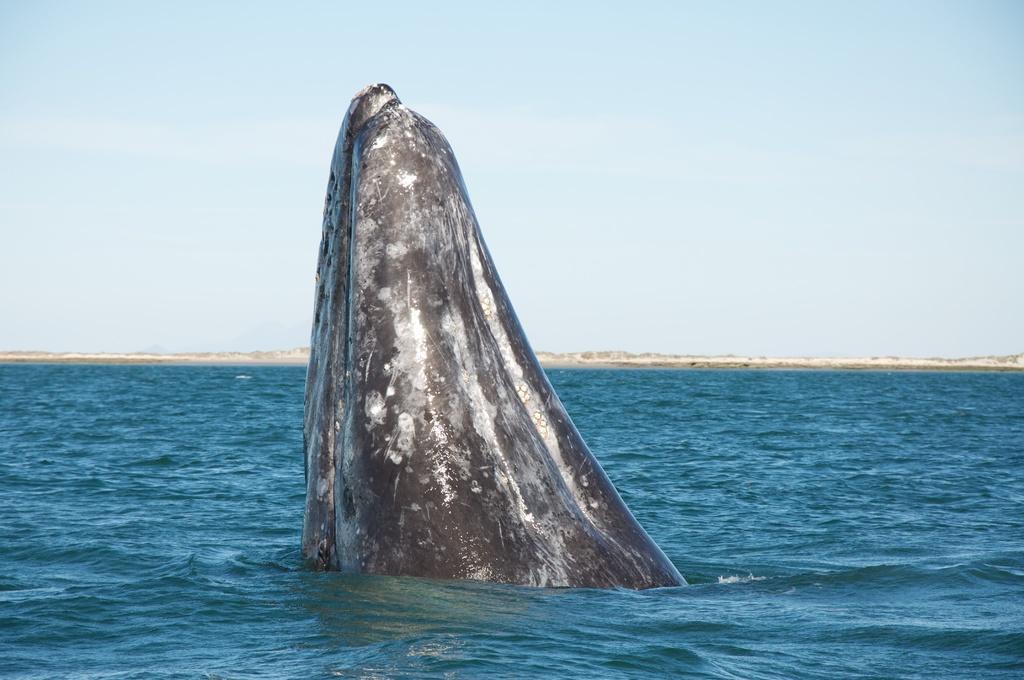Please provide a concise description of this image. In the center of the image we can see a whale in the water. In the background there is sky. 